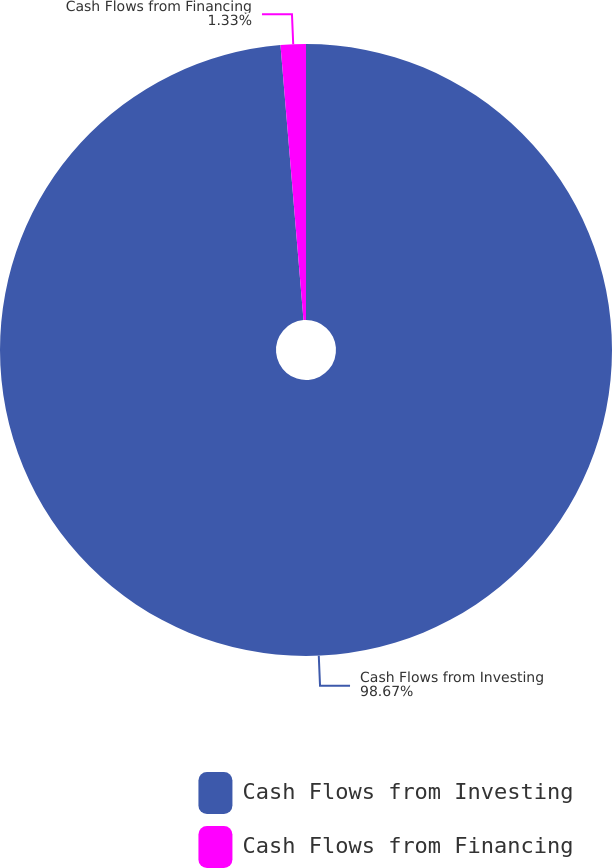Convert chart. <chart><loc_0><loc_0><loc_500><loc_500><pie_chart><fcel>Cash Flows from Investing<fcel>Cash Flows from Financing<nl><fcel>98.67%<fcel>1.33%<nl></chart> 